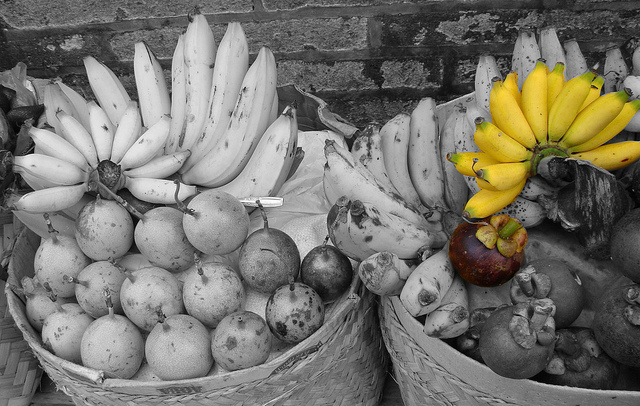Please provide a short description for this region: [0.26, 0.19, 0.47, 0.52]. Rightmost four bananas in the left bucket. 